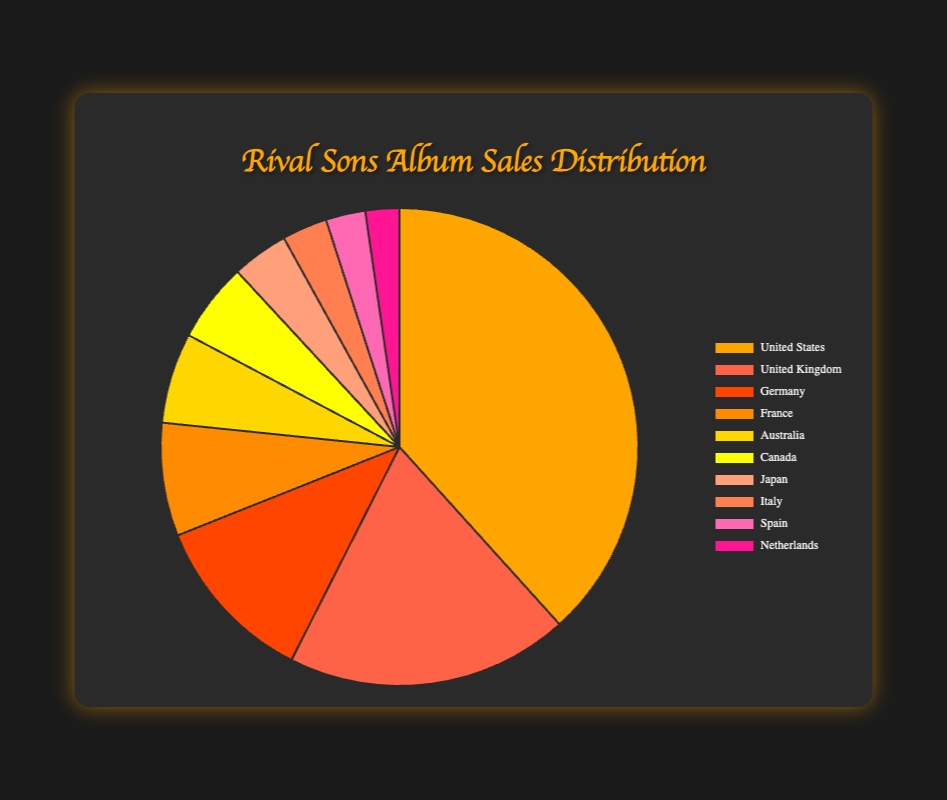which country has the highest album sales? The country with the highest album sales is the United States. This is indicated by the largest slice of the pie chart, representing 500,000 sales.
Answer: United States How many more album sales does the United States have compared to the United Kingdom? The United States has 500,000 album sales and the United Kingdom has 250,000. The difference is 500,000 - 250,000 = 250,000.
Answer: 250,000 What is the combined album sales for France and Germany? Germany has 150,000 sales, and France has 100,000 sales. The combined total is 150,000 + 100,000 = 250,000.
Answer: 250,000 Which countries have less than 100,000 album sales? The countries with less than 100,000 album sales are Australia, Canada, Japan, Italy, Spain, and the Netherlands, as indicated by the smaller slices on the pie chart.
Answer: Australia, Canada, Japan, Italy, Spain, Netherlands Which country's album sales are closest to 50,000? Japan's album sales are closest to 50,000, as indicated by its slice on the pie chart which represents exactly 50,000 sales.
Answer: Japan How many countries have album sales greater than or equal to 100,000? The countries with album sales greater than or equal to 100,000 are United States, United Kingdom, Germany, and France, totaling four countries.
Answer: 4 What is the average album sales for the top three countries? The top three countries are the United States (500,000), United Kingdom (250,000), and Germany (150,000). The average sales are (500,000 + 250,000 + 150,000) / 3 = 300,000.
Answer: 300,000 Which country has the smallest album sales and what is the amount? The Netherlands has the smallest album sales with 30,000, as indicated by the smallest slice on the pie chart.
Answer: Netherlands, 30,000 What proportion of the total album sales do the United States and the United Kingdom together represent? The total album sales for all countries is 1,305,000. The sales for the United States and United Kingdom together are 500,000 + 250,000 = 750,000. The proportion is 750,000 / 1,305,000 ≈ 0.575, or 57.5%.
Answer: 57.5% If you combine the sales of Japan, Italy, Spain, and the Netherlands, do they exceed the sales of Germany? The combined sales of Japan (50,000), Italy (40,000), Spain (35,000), and the Netherlands (30,000) is 50,000 + 40,000 + 35,000 + 30,000 = 155,000. Germany has 150,000 sales, so yes, the combined sales exceed Germany's.
Answer: Yes 